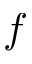Convert formula to latex. <formula><loc_0><loc_0><loc_500><loc_500>f</formula> 